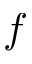Convert formula to latex. <formula><loc_0><loc_0><loc_500><loc_500>f</formula> 